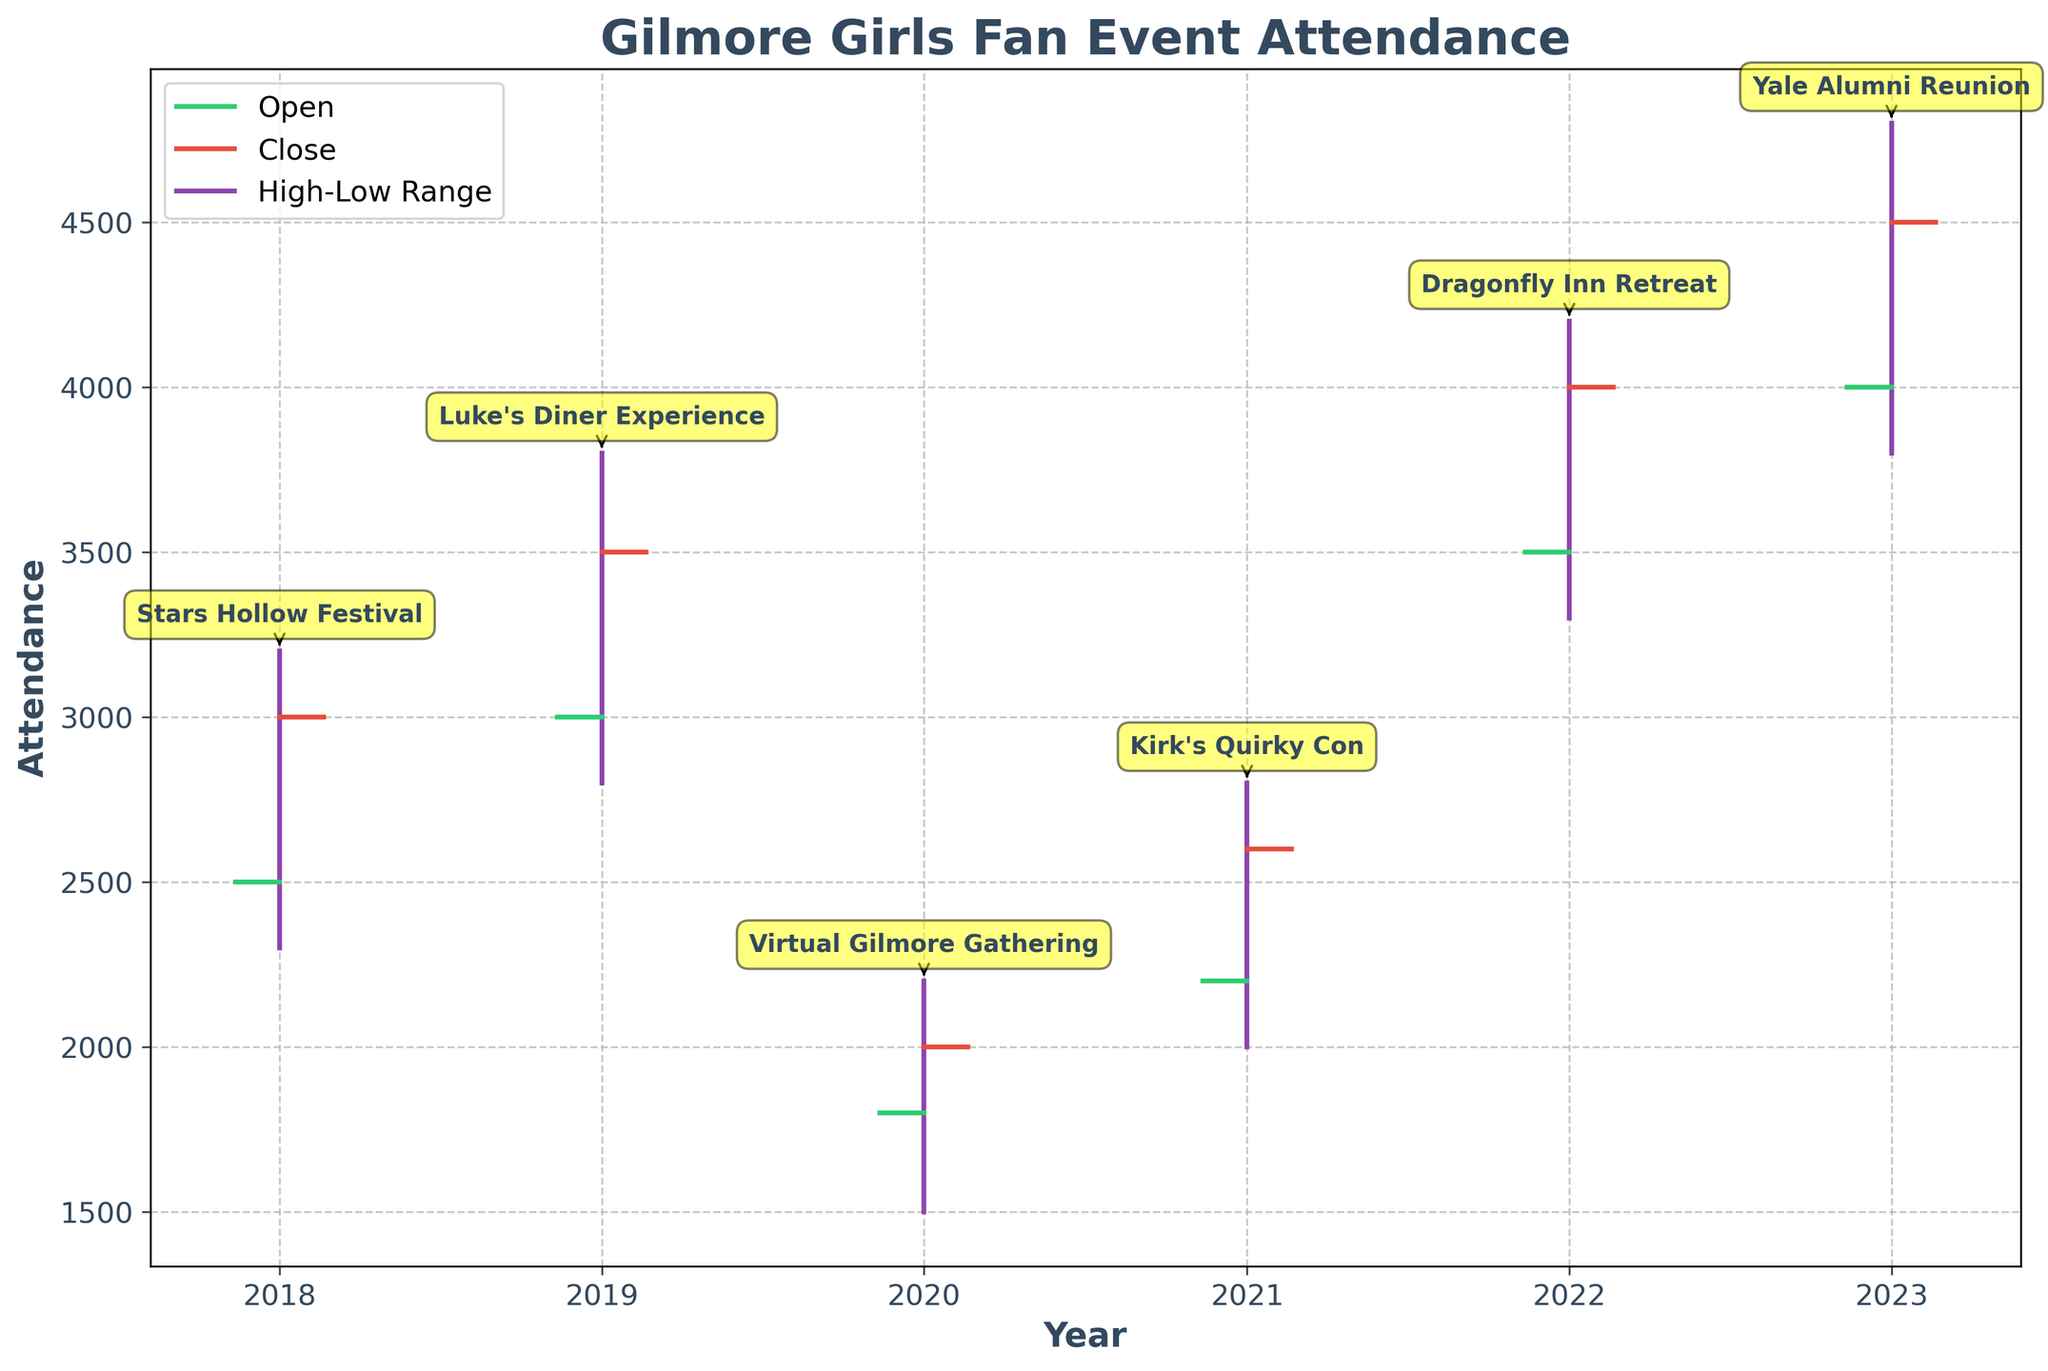What is the title of the plot? The title of the plot is located at the top of the figure, which describes the overall content of the chart. It reads "Gilmore Girls Fan Event Attendance".
Answer: Gilmore Girls Fan Event Attendance What are the labels on the x-axis and y-axis? The x-axis is labeled with the years from 2018 to 2023, and the y-axis is labeled "Attendance". These labels are used to define the Time and Attendance category the plot is measuring.
Answer: Year, Attendance Which event had the highest attendance recorded during its peak? To find the event with the highest recorded attendance, check the highest points (High) on the vertical lines. The year 2023, Yale Alumni Reunion, reaches 4800, which is the highest.
Answer: Yale Alumni Reunion What was the closing attendance of "Stars Hollow Festival" in 2018? Locate the 2018 data point for the "Stars Hollow Festival." The close attendance figure is the position on the right tick, which is 3000.
Answer: 3000 What event saw the largest increase in attendance from opening to closing? Compare the difference between opening and closing attendance for each event: 
- 2018: 3000 - 2500 = 500
- 2019: 3500 - 3000 = 500
- 2020: 2000 - 1800 = 200
- 2021: 2600 - 2200 = 400
- 2022: 4000 - 3500 = 500
- 2023: 4500 - 4000 = 500
Several events see the largest increase of 500 attendees: Stars Hollow Festival (2018), Luke's Diner Experience (2019), Dragonfly Inn Retreat (2022), and Yale Alumni Reunion (2023).
Answer: Stars Hollow Festival, Luke's Diner Experience, Dragonfly Inn Retreat, Yale Alumni Reunion How did the attendance at "Virtual Gilmore Gathering" in 2020 compare to "Kirk's Quirky Con" in 2021 in terms of high and low figures? For 2020, the high and low are 2200 and 1500 respectively. For 2021, the high and low are 2800 and 2000. 
So, in comparison:
- High in 2020: 2200 vs. High in 2021: 2800
- Low in 2020: 1500 vs. Low in 2021: 2000
"Kirk's Quirky Con" has both higher high and low attendance figures than "Virtual Gilmore Gathering."
Answer: Kirk's Quirky Con had higher attendance figures Between which two consecutive years was the biggest increase in peak attendance observed? Check the high attendance from one year to the next:
- 2018 to 2019: 3800 - 3200 = 600
- 2019 to 2020: 2200 - 3800 = -1600
- 2020 to 2021: 2800 - 2200 = 600
- 2021 to 2022: 4200 - 2800 = 1400
- 2022 to 2023: 4800 - 4200 = 600
The largest increase is from 2021 to 2022, a step-by-step look reveals an increase of 1400.
Answer: 2021 to 2022 What is the average closings attendance for all the events from 2018 to 2023? Find the closing figures for each event and compute their average:
(3000 + 3500 + 2000 + 2600 + 4000 + 4500) / 6 = 22600 / 6 = 3767
Answer: 3767 Which event shows the smallest range between its high and low attendance figures? Calculate the range (High - Low) for each event and compare:
- 2018: 3200 - 2300 = 900
- 2019: 3800 - 2800 = 1000
- 2020: 2200 - 1500 = 700
- 2021: 2800 - 2000 = 800
- 2022: 4200 - 3300 = 900
- 2023: 4800 - 3800 = 1000
The smallest range is 700, for "Virtual Gilmore Gathering" in 2020.
Answer: Virtual Gilmore Gathering 